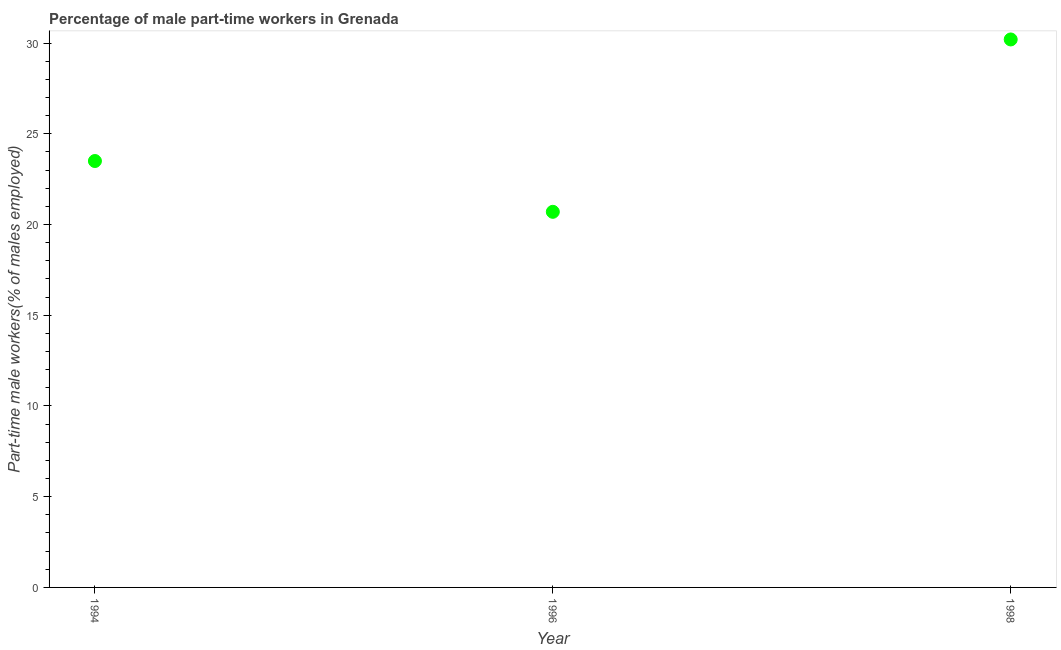What is the percentage of part-time male workers in 1996?
Provide a succinct answer. 20.7. Across all years, what is the maximum percentage of part-time male workers?
Offer a terse response. 30.2. Across all years, what is the minimum percentage of part-time male workers?
Your answer should be compact. 20.7. In which year was the percentage of part-time male workers maximum?
Provide a short and direct response. 1998. In which year was the percentage of part-time male workers minimum?
Your answer should be compact. 1996. What is the sum of the percentage of part-time male workers?
Keep it short and to the point. 74.4. What is the difference between the percentage of part-time male workers in 1994 and 1996?
Offer a very short reply. 2.8. What is the average percentage of part-time male workers per year?
Ensure brevity in your answer.  24.8. Do a majority of the years between 1996 and 1998 (inclusive) have percentage of part-time male workers greater than 15 %?
Offer a very short reply. Yes. What is the ratio of the percentage of part-time male workers in 1996 to that in 1998?
Make the answer very short. 0.69. Is the percentage of part-time male workers in 1994 less than that in 1996?
Ensure brevity in your answer.  No. Is the difference between the percentage of part-time male workers in 1994 and 1998 greater than the difference between any two years?
Ensure brevity in your answer.  No. What is the difference between the highest and the second highest percentage of part-time male workers?
Your response must be concise. 6.7. What is the difference between the highest and the lowest percentage of part-time male workers?
Keep it short and to the point. 9.5. In how many years, is the percentage of part-time male workers greater than the average percentage of part-time male workers taken over all years?
Offer a terse response. 1. How many years are there in the graph?
Your answer should be compact. 3. What is the difference between two consecutive major ticks on the Y-axis?
Provide a succinct answer. 5. Are the values on the major ticks of Y-axis written in scientific E-notation?
Provide a short and direct response. No. Does the graph contain any zero values?
Give a very brief answer. No. Does the graph contain grids?
Offer a terse response. No. What is the title of the graph?
Provide a short and direct response. Percentage of male part-time workers in Grenada. What is the label or title of the X-axis?
Your answer should be very brief. Year. What is the label or title of the Y-axis?
Your response must be concise. Part-time male workers(% of males employed). What is the Part-time male workers(% of males employed) in 1996?
Ensure brevity in your answer.  20.7. What is the Part-time male workers(% of males employed) in 1998?
Give a very brief answer. 30.2. What is the difference between the Part-time male workers(% of males employed) in 1994 and 1996?
Give a very brief answer. 2.8. What is the difference between the Part-time male workers(% of males employed) in 1994 and 1998?
Provide a succinct answer. -6.7. What is the difference between the Part-time male workers(% of males employed) in 1996 and 1998?
Provide a succinct answer. -9.5. What is the ratio of the Part-time male workers(% of males employed) in 1994 to that in 1996?
Your answer should be compact. 1.14. What is the ratio of the Part-time male workers(% of males employed) in 1994 to that in 1998?
Offer a terse response. 0.78. What is the ratio of the Part-time male workers(% of males employed) in 1996 to that in 1998?
Offer a terse response. 0.69. 